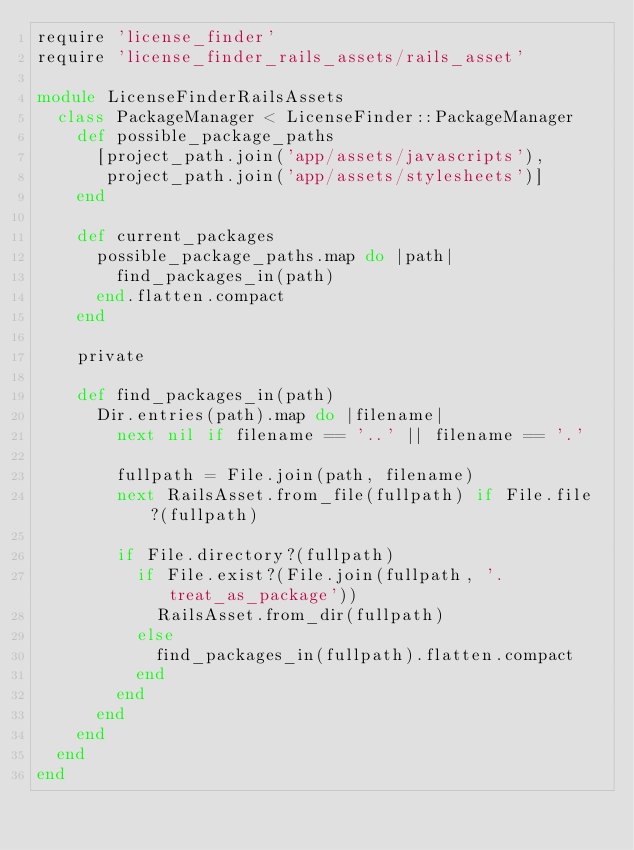Convert code to text. <code><loc_0><loc_0><loc_500><loc_500><_Ruby_>require 'license_finder'
require 'license_finder_rails_assets/rails_asset'

module LicenseFinderRailsAssets
  class PackageManager < LicenseFinder::PackageManager
    def possible_package_paths
      [project_path.join('app/assets/javascripts'),
       project_path.join('app/assets/stylesheets')]
    end

    def current_packages
      possible_package_paths.map do |path|
        find_packages_in(path)
      end.flatten.compact
    end

    private

    def find_packages_in(path)
      Dir.entries(path).map do |filename|
        next nil if filename == '..' || filename == '.'

        fullpath = File.join(path, filename)
        next RailsAsset.from_file(fullpath) if File.file?(fullpath)

        if File.directory?(fullpath)
          if File.exist?(File.join(fullpath, '.treat_as_package'))
            RailsAsset.from_dir(fullpath)
          else
            find_packages_in(fullpath).flatten.compact
          end
        end
      end
    end
  end
end
</code> 